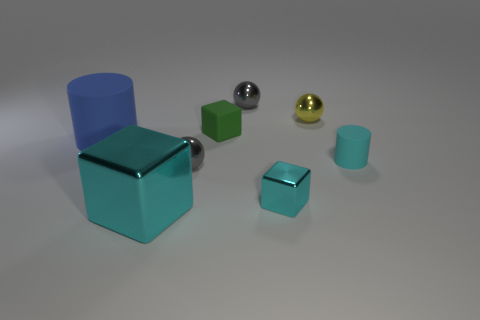Add 1 cyan metal things. How many objects exist? 9 Subtract all spheres. How many objects are left? 5 Subtract all small cyan metal objects. Subtract all cyan cylinders. How many objects are left? 6 Add 7 gray metallic things. How many gray metallic things are left? 9 Add 2 small metal balls. How many small metal balls exist? 5 Subtract 0 gray cylinders. How many objects are left? 8 